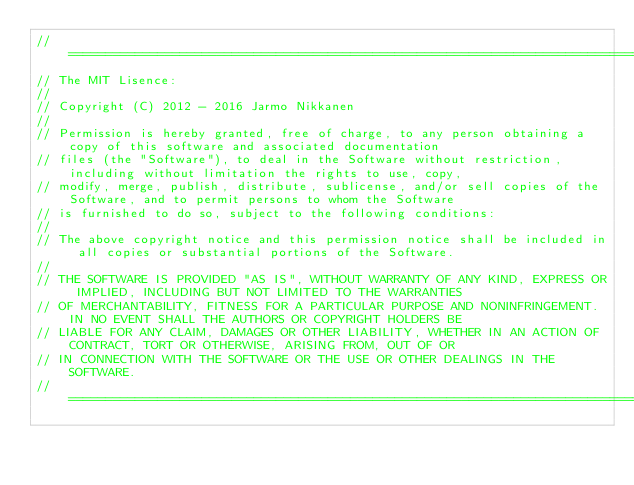Convert code to text. <code><loc_0><loc_0><loc_500><loc_500><_C++_>// =================================================================================================================================
// The MIT Lisence:
//
// Copyright (C) 2012 - 2016 Jarmo Nikkanen
//
// Permission is hereby granted, free of charge, to any person obtaining a copy of this software and associated documentation 
// files (the "Software"), to deal in the Software without restriction, including without limitation the rights to use, copy, 
// modify, merge, publish, distribute, sublicense, and/or sell copies of the Software, and to permit persons to whom the Software 
// is furnished to do so, subject to the following conditions:
//
// The above copyright notice and this permission notice shall be included in all copies or substantial portions of the Software.
//
// THE SOFTWARE IS PROVIDED "AS IS", WITHOUT WARRANTY OF ANY KIND, EXPRESS OR IMPLIED, INCLUDING BUT NOT LIMITED TO THE WARRANTIES
// OF MERCHANTABILITY, FITNESS FOR A PARTICULAR PURPOSE AND NONINFRINGEMENT. IN NO EVENT SHALL THE AUTHORS OR COPYRIGHT HOLDERS BE
// LIABLE FOR ANY CLAIM, DAMAGES OR OTHER LIABILITY, WHETHER IN AN ACTION OF CONTRACT, TORT OR OTHERWISE, ARISING FROM, OUT OF OR
// IN CONNECTION WITH THE SOFTWARE OR THE USE OR OTHER DEALINGS IN THE SOFTWARE.
// =================================================================================================================================
</code> 